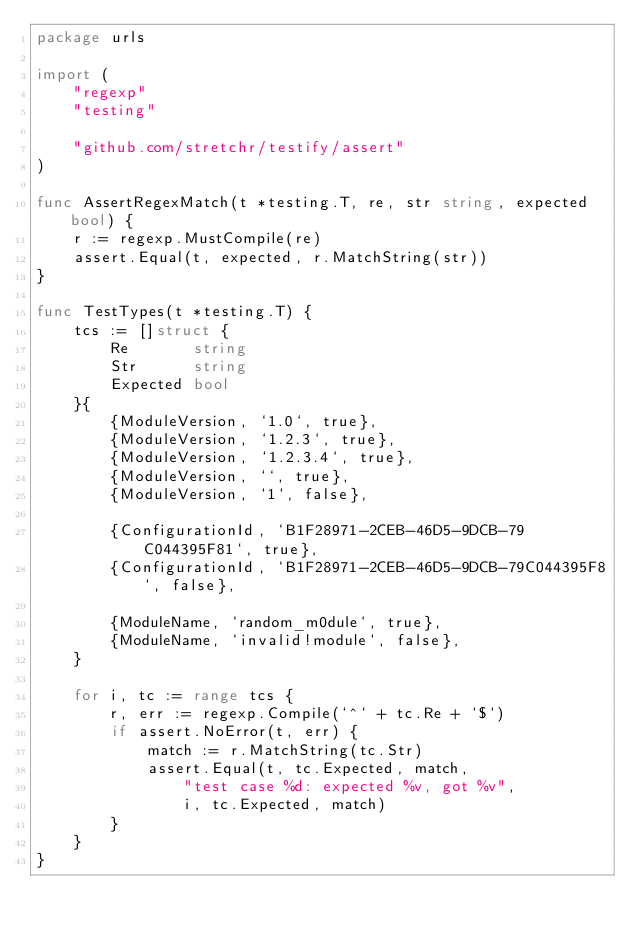Convert code to text. <code><loc_0><loc_0><loc_500><loc_500><_Go_>package urls

import (
	"regexp"
	"testing"

	"github.com/stretchr/testify/assert"
)

func AssertRegexMatch(t *testing.T, re, str string, expected bool) {
	r := regexp.MustCompile(re)
	assert.Equal(t, expected, r.MatchString(str))
}

func TestTypes(t *testing.T) {
	tcs := []struct {
		Re       string
		Str      string
		Expected bool
	}{
		{ModuleVersion, `1.0`, true},
		{ModuleVersion, `1.2.3`, true},
		{ModuleVersion, `1.2.3.4`, true},
		{ModuleVersion, ``, true},
		{ModuleVersion, `1`, false},

		{ConfigurationId, `B1F28971-2CEB-46D5-9DCB-79C044395F81`, true},
		{ConfigurationId, `B1F28971-2CEB-46D5-9DCB-79C044395F8`, false},

		{ModuleName, `random_m0dule`, true},
		{ModuleName, `invalid!module`, false},
	}

	for i, tc := range tcs {
		r, err := regexp.Compile(`^` + tc.Re + `$`)
		if assert.NoError(t, err) {
			match := r.MatchString(tc.Str)
			assert.Equal(t, tc.Expected, match,
				"test case %d: expected %v, got %v",
				i, tc.Expected, match)
		}
	}
}
</code> 